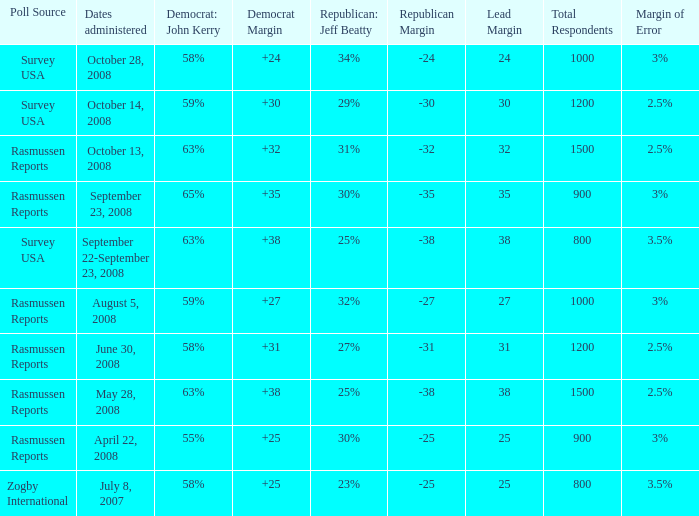Who is the poll source that has Republican: Jeff Beatty behind at 27%? Rasmussen Reports. 